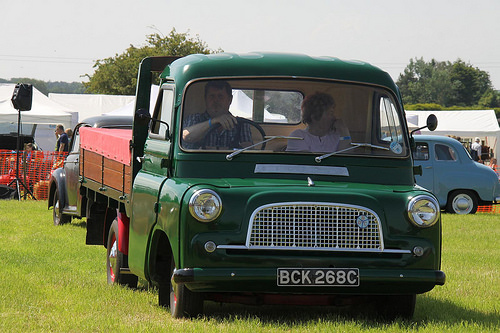<image>
Can you confirm if the wheel is behind the man? No. The wheel is not behind the man. From this viewpoint, the wheel appears to be positioned elsewhere in the scene. 